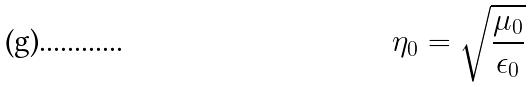<formula> <loc_0><loc_0><loc_500><loc_500>\eta _ { 0 } = \sqrt { \frac { \mu _ { 0 } } { \epsilon _ { 0 } } }</formula> 